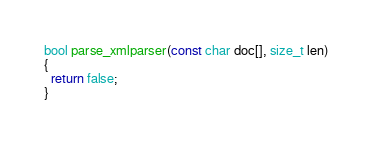Convert code to text. <code><loc_0><loc_0><loc_500><loc_500><_C++_>bool parse_xmlparser(const char doc[], size_t len)
{
  return false;
}
</code> 